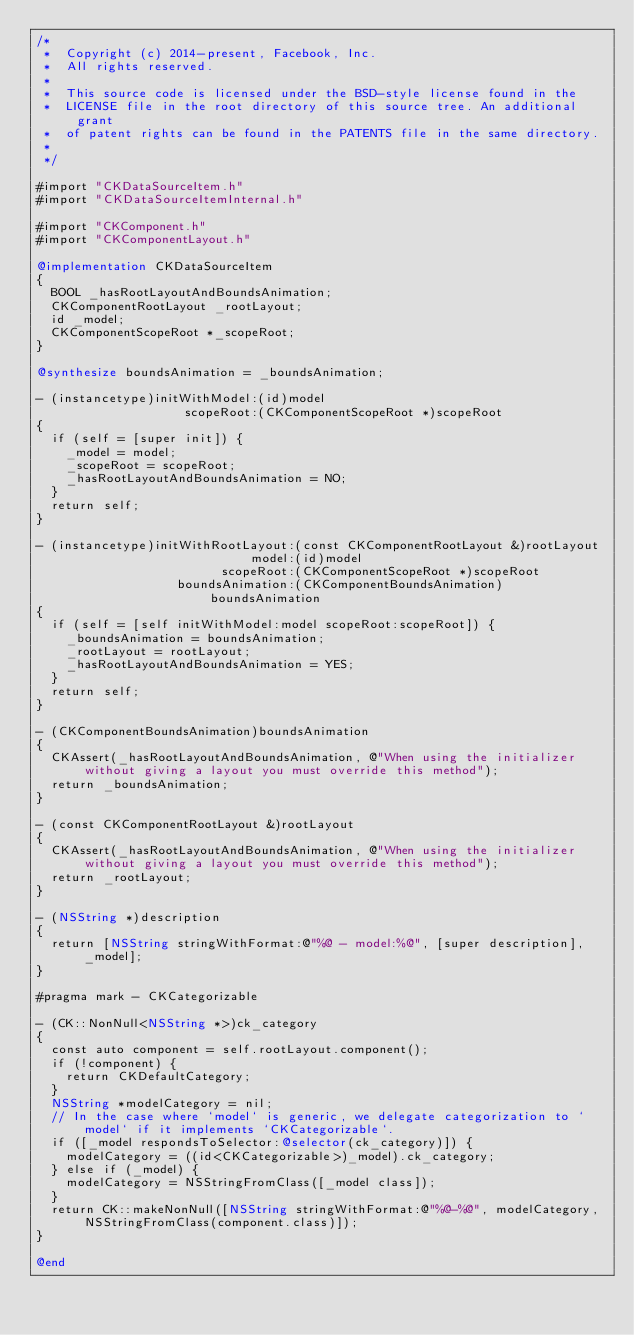<code> <loc_0><loc_0><loc_500><loc_500><_ObjectiveC_>/*
 *  Copyright (c) 2014-present, Facebook, Inc.
 *  All rights reserved.
 *
 *  This source code is licensed under the BSD-style license found in the
 *  LICENSE file in the root directory of this source tree. An additional grant
 *  of patent rights can be found in the PATENTS file in the same directory.
 *
 */

#import "CKDataSourceItem.h"
#import "CKDataSourceItemInternal.h"

#import "CKComponent.h"
#import "CKComponentLayout.h"

@implementation CKDataSourceItem
{
  BOOL _hasRootLayoutAndBoundsAnimation;
  CKComponentRootLayout _rootLayout;
  id _model;
  CKComponentScopeRoot *_scopeRoot;
}

@synthesize boundsAnimation = _boundsAnimation;

- (instancetype)initWithModel:(id)model
                    scopeRoot:(CKComponentScopeRoot *)scopeRoot
{
  if (self = [super init]) {
    _model = model;
    _scopeRoot = scopeRoot;
    _hasRootLayoutAndBoundsAnimation = NO;
  }
  return self;
}

- (instancetype)initWithRootLayout:(const CKComponentRootLayout &)rootLayout
                             model:(id)model
                         scopeRoot:(CKComponentScopeRoot *)scopeRoot
                   boundsAnimation:(CKComponentBoundsAnimation)boundsAnimation
{
  if (self = [self initWithModel:model scopeRoot:scopeRoot]) {
    _boundsAnimation = boundsAnimation;
    _rootLayout = rootLayout;
    _hasRootLayoutAndBoundsAnimation = YES;
  }
  return self;
}

- (CKComponentBoundsAnimation)boundsAnimation
{
  CKAssert(_hasRootLayoutAndBoundsAnimation, @"When using the initializer without giving a layout you must override this method");
  return _boundsAnimation;
}

- (const CKComponentRootLayout &)rootLayout
{
  CKAssert(_hasRootLayoutAndBoundsAnimation, @"When using the initializer without giving a layout you must override this method");
  return _rootLayout;
}

- (NSString *)description
{
  return [NSString stringWithFormat:@"%@ - model:%@", [super description], _model];
}

#pragma mark - CKCategorizable

- (CK::NonNull<NSString *>)ck_category
{
  const auto component = self.rootLayout.component();
  if (!component) {
    return CKDefaultCategory;
  }
  NSString *modelCategory = nil;
  // In the case where `model` is generic, we delegate categorization to `model` if it implements `CKCategorizable`.
  if ([_model respondsToSelector:@selector(ck_category)]) {
    modelCategory = ((id<CKCategorizable>)_model).ck_category;
  } else if (_model) {
    modelCategory = NSStringFromClass([_model class]);
  }
  return CK::makeNonNull([NSString stringWithFormat:@"%@-%@", modelCategory, NSStringFromClass(component.class)]);
}

@end
</code> 